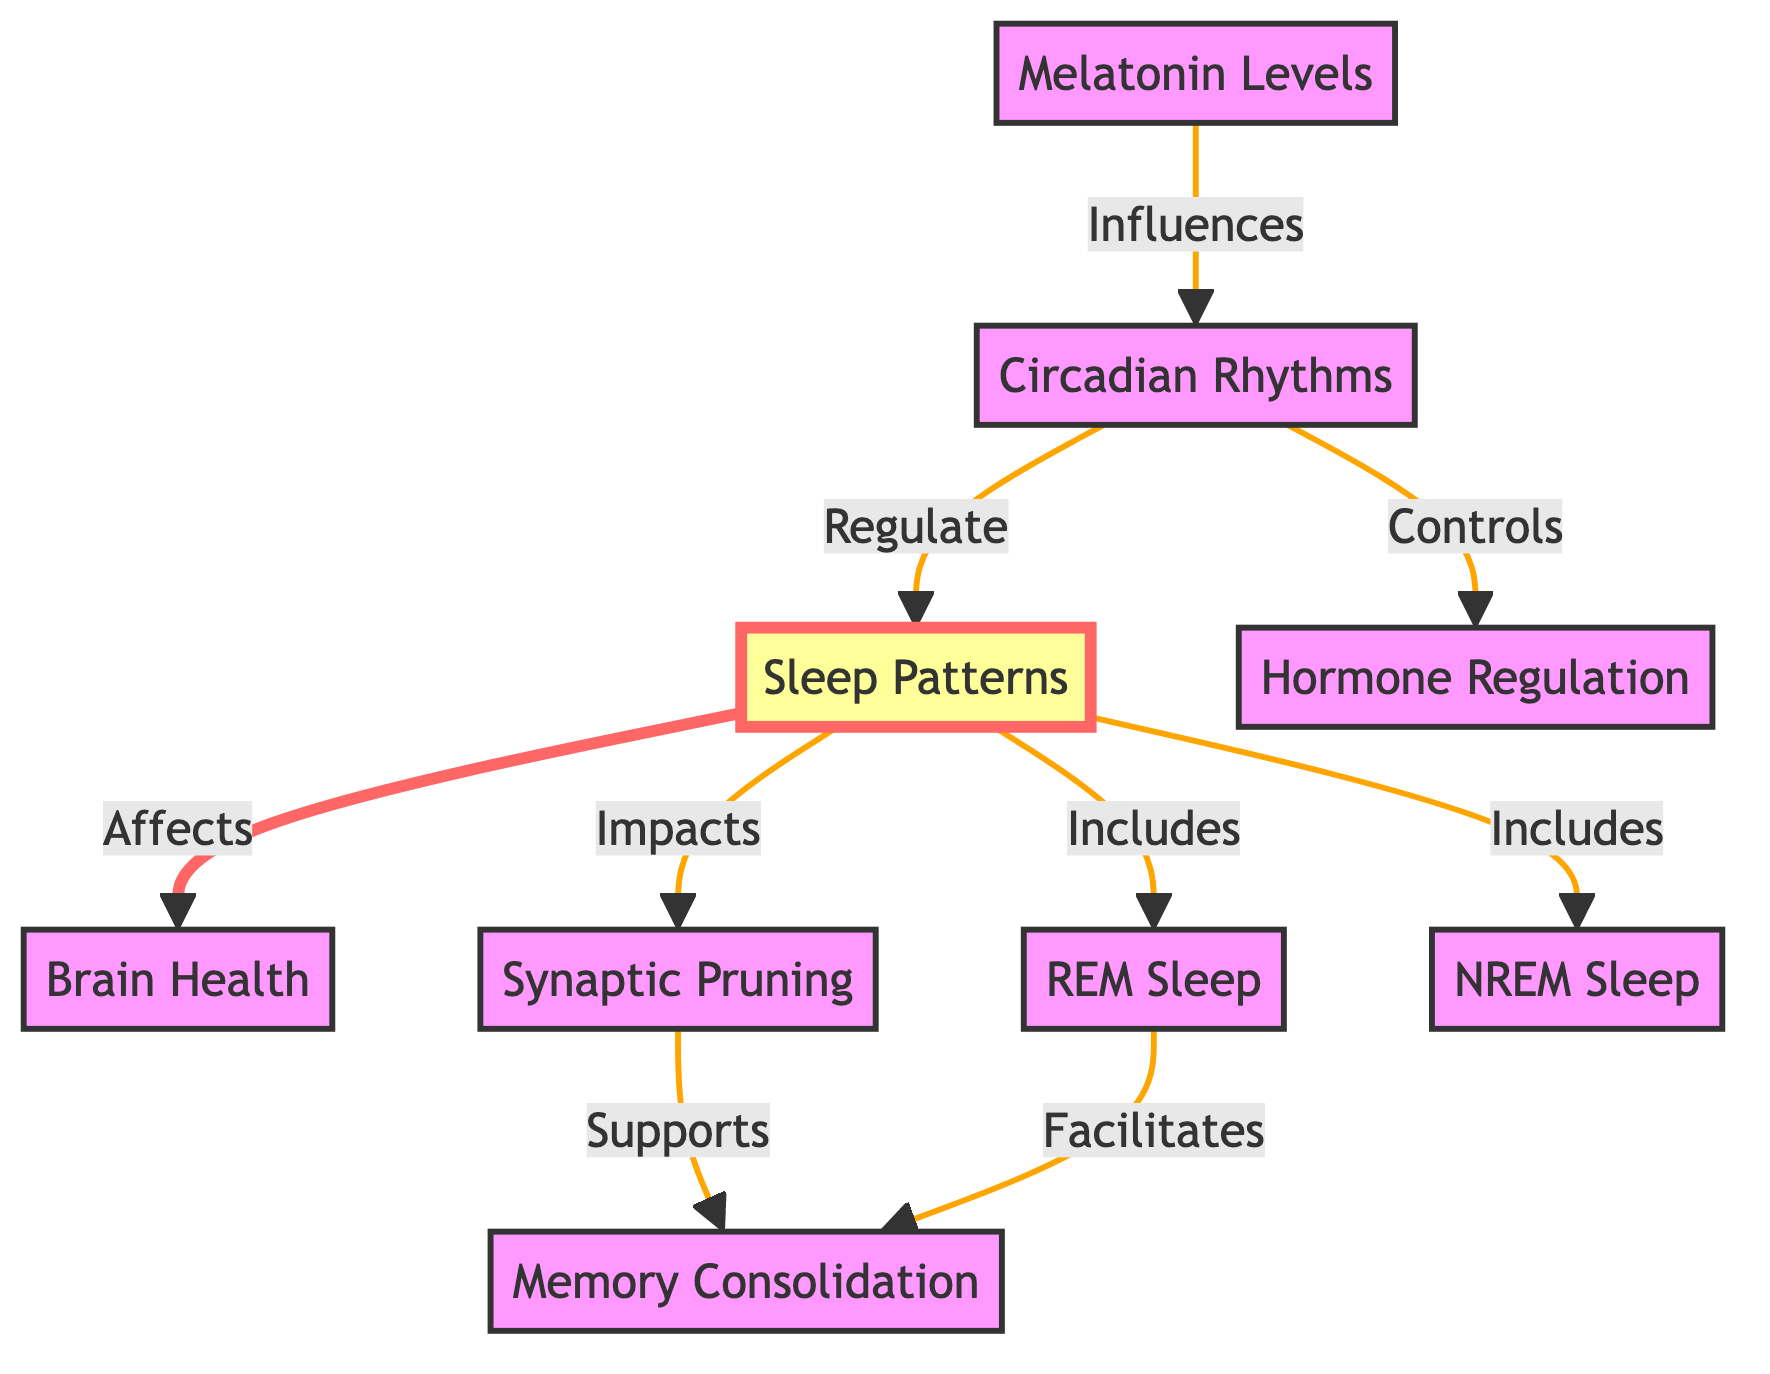What are the two types of sleep included in sleep patterns? The diagram shows "REM Sleep" and "NREM Sleep" as two components that fall under "Sleep Patterns." These nodes directly connect to the "Sleep Patterns" node, indicating their inclusion.
Answer: REM Sleep, NREM Sleep How does melatonin affect circadian rhythms? According to the diagram, "Melatonin" is shown to influence "Circadian Rhythms." This relationship suggests that melatonin has a direct impact on regulating the body's internal clock or natural rhythms.
Answer: Influences What does synaptic pruning support? The diagram indicates that "Synaptic Pruning" supports "Memory Consolidation." This means that effective synaptic pruning is crucial for enhancing memory function and learning.
Answer: Memory Consolidation How many main components are shown in the diagram? By counting the nodes in the diagram, there are six main components: "Sleep Patterns," "Brain Health," "Circadian Rhythms," "Synaptic Pruning," "Melatonin Levels," and "Memory Consolidation".
Answer: Six What regulates sleep patterns? The relationship shown in the diagram indicates that "Circadian Rhythms" regulate "Sleep Patterns." This means the body's internal clock plays a significant role in determining when we sleep.
Answer: Circadian Rhythms Which type of sleep facilitates memory consolidation? The diagram specifies that "REM Sleep" facilitates "Memory Consolidation." This connection emphasizes the importance of REM sleep in the learning process and memory retention.
Answer: REM Sleep What is the connection between circadian rhythms and hormone regulation? The diagram illustrates that "Circadian Rhythms" control "Hormone Regulation." This shows that our body's internal clock not only influences sleep but also affects hormone levels.
Answer: Controls What is the effect of sleep patterns on brain health? The diagram clearly states that "Sleep Patterns" affect "Brain Health." This implies that how well teenagers sleep can significantly impact their overall brain function and health.
Answer: Affects What supports memory consolidation besides synaptic pruning? The diagram suggests that "REM Sleep" also supports "Memory Consolidation," indicating there are at least two factors related to memory: synaptic pruning and REM sleep.
Answer: REM Sleep 